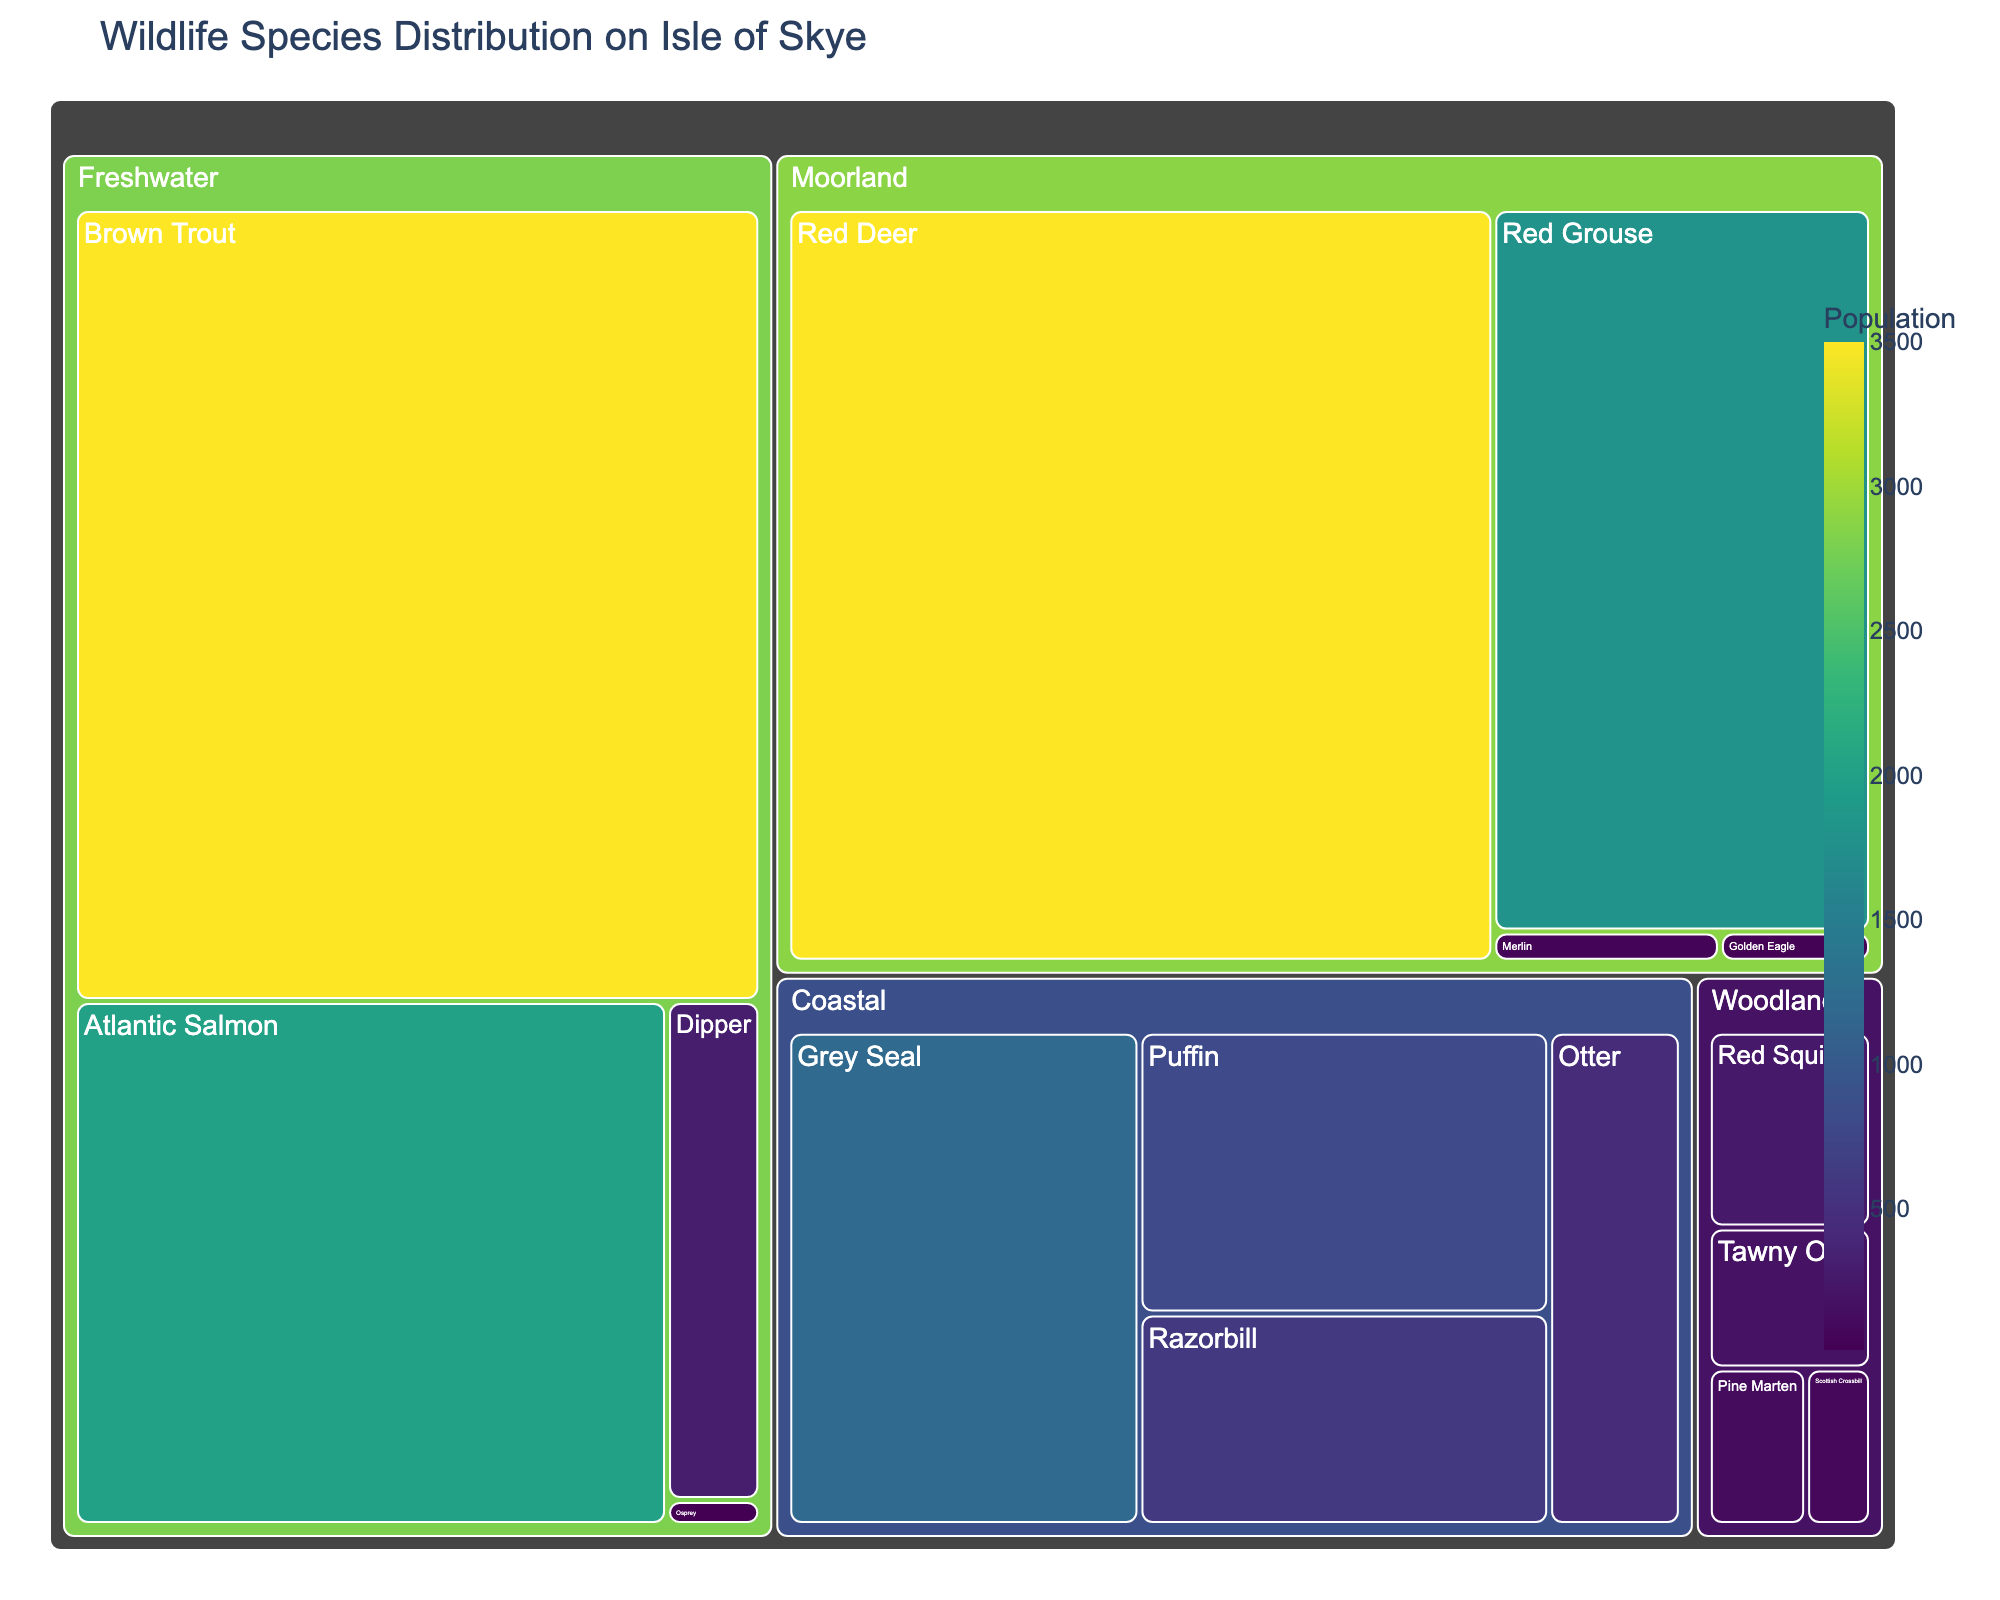What's the most populous species in the coastal habitat? To find the most populous species in the coastal habitat, look at the species within the "Coastal" category and compare their population numbers. Grey Seal has the highest population with 1200.
Answer: Grey Seal How many species are present in the woodland habitat? To determine the number of species in the woodland habitat, count the unique species listed under "Woodland." They are Pine Marten, Scottish Crossbill, Red Squirrel, and Tawny Owl, totaling four species.
Answer: Four Which habitat has the least diversity in terms of the number of species? Compare the number of unique species in each habitat. The habitat with the fewest species is "Freshwater," which has four species: Atlantic Salmon, Brown Trout, Dipper, and Osprey.
Answer: Freshwater What is the combined population of species in the moorland habitat? Add the populations of all species in the moorland habitat: Red Deer (3500), Golden Eagle (30), Merlin (45), and Red Grouse (1800). The total is 3500 + 30 + 45 + 1800 = 5375.
Answer: 5375 Which species has the smallest population on the Isle of Skye? Identify the species with the smallest population by comparing all population figures. The Osprey in the freshwater habitat has the smallest population of 15.
Answer: Osprey What is the population difference between Red Deer and Red Grouse? Subtract the population of Red Grouse (1800) from the population of Red Deer (3500): 3500 - 1800 = 1700.
Answer: 1700 Which habitat contains the highest total population of wildlife? Sum the populations for each habitat and compare them. Coastal: 450 + 1200 + 800 + 600 = 3050, Moorland: 3500 + 30 + 45 + 1800 = 5375, Woodland: 120 + 80 + 250 + 180 = 630, Freshwater: 2000 + 3500 + 300 + 15 = 5815. Freshwater has the highest total population.
Answer: Freshwater Is the population of the Puffin greater than that of the Tawny Owl? Compare the population numbers for Puffin (800) and Tawny Owl (180). The Puffin population is greater.
Answer: Yes How does the size of the Dipper population compare to the Merlin population? Compare the population numbers for Dipper (300) and Merlin (45). The Dipper population is larger.
Answer: Dipper population is larger Which species in the freshwater habitat has the second-largest population? Identify the species in the freshwater habitat and compare their populations: Atlantic Salmon (2000), Brown Trout (3500), Dipper (300), and Osprey (15). The second-largest population is Atlantic Salmon with 2000.
Answer: Atlantic Salmon 